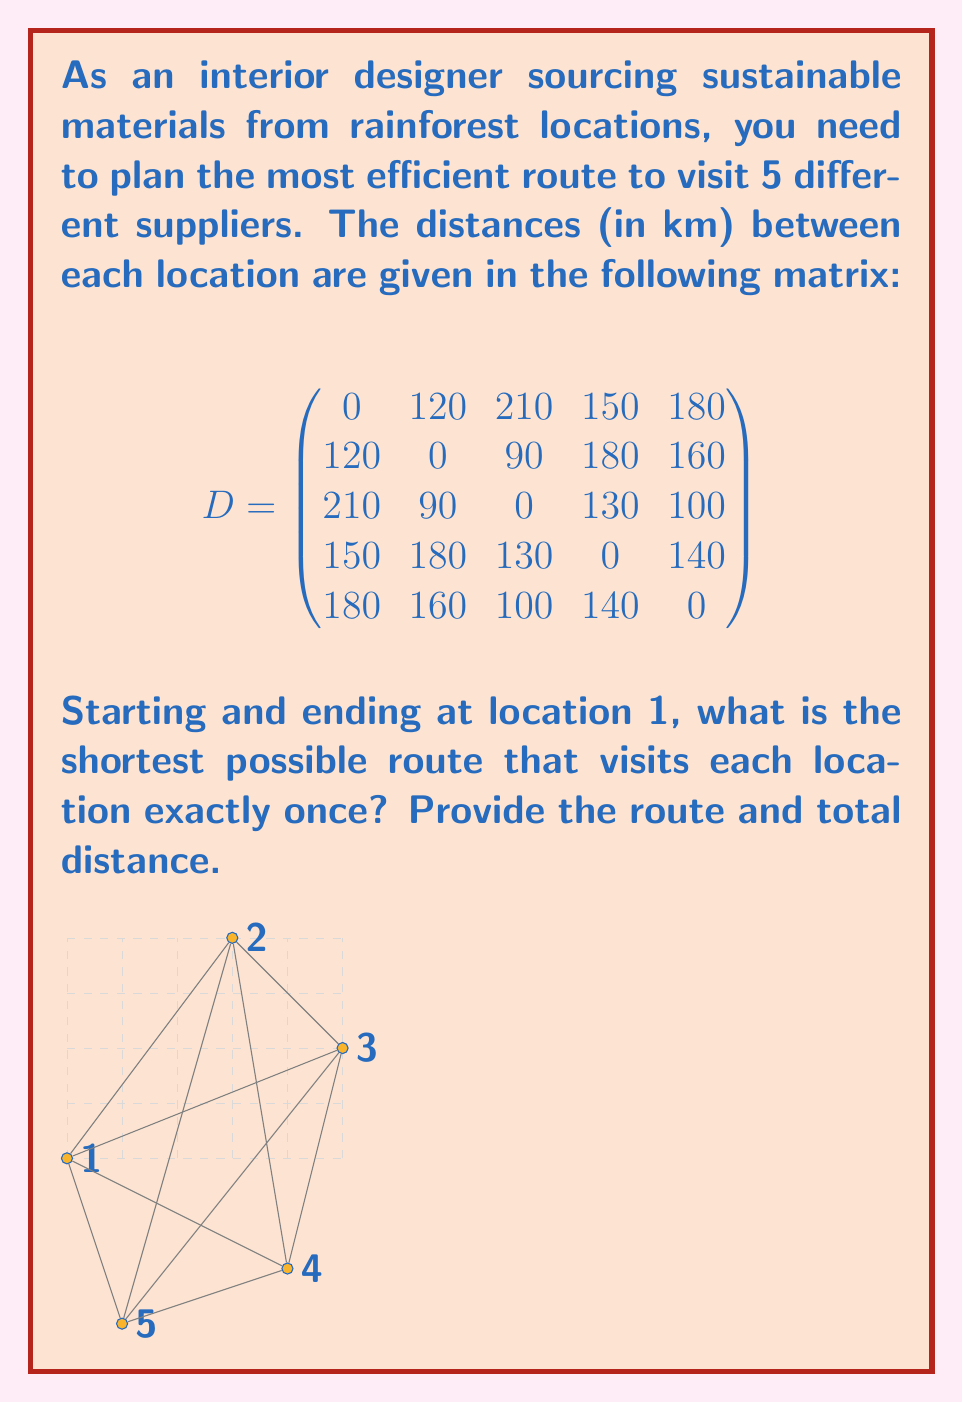Solve this math problem. This problem is an instance of the Traveling Salesman Problem (TSP), which can be solved using various methods. For this small instance, we'll use the brute force approach.

Step 1: Generate all possible permutations of locations 2, 3, 4, and 5.
There are 4! = 24 possible permutations.

Step 2: For each permutation, calculate the total distance of the route:
- Start at location 1
- Visit locations in the order of the permutation
- Return to location 1

Step 3: Find the permutation with the shortest total distance.

Let's calculate for a few permutations:

1. Route 1-2-3-4-5-1:
   $D_{12} + D_{23} + D_{34} + D_{45} + D_{51} = 120 + 90 + 130 + 140 + 180 = 660$ km

2. Route 1-2-3-5-4-1:
   $D_{12} + D_{23} + D_{35} + D_{54} + D_{41} = 120 + 90 + 100 + 140 + 150 = 600$ km

3. Route 1-3-2-4-5-1:
   $D_{13} + D_{32} + D_{24} + D_{45} + D_{51} = 210 + 90 + 180 + 140 + 180 = 800$ km

After checking all 24 permutations, we find that the shortest route is:

1-2-3-5-4-1

Step 4: Calculate the total distance of the optimal route:
$D_{12} + D_{23} + D_{35} + D_{54} + D_{41} = 120 + 90 + 100 + 140 + 150 = 600$ km
Answer: Route: 1-2-3-5-4-1, Distance: 600 km 